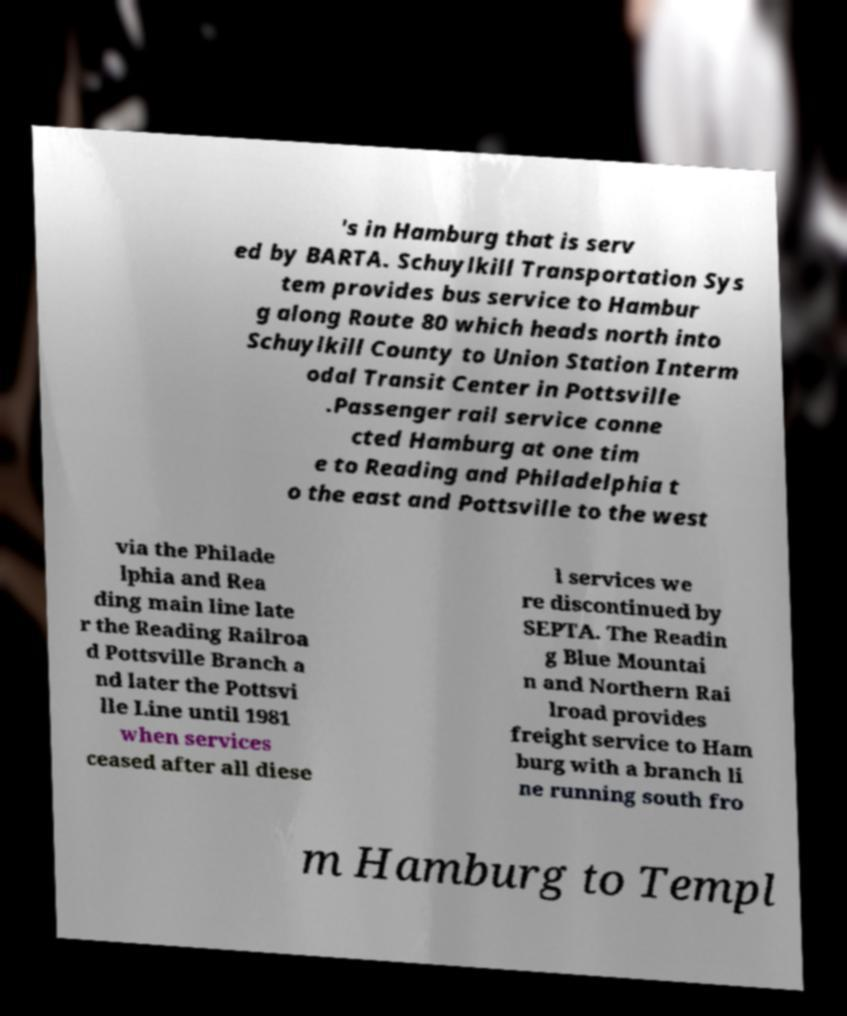Please read and relay the text visible in this image. What does it say? 's in Hamburg that is serv ed by BARTA. Schuylkill Transportation Sys tem provides bus service to Hambur g along Route 80 which heads north into Schuylkill County to Union Station Interm odal Transit Center in Pottsville .Passenger rail service conne cted Hamburg at one tim e to Reading and Philadelphia t o the east and Pottsville to the west via the Philade lphia and Rea ding main line late r the Reading Railroa d Pottsville Branch a nd later the Pottsvi lle Line until 1981 when services ceased after all diese l services we re discontinued by SEPTA. The Readin g Blue Mountai n and Northern Rai lroad provides freight service to Ham burg with a branch li ne running south fro m Hamburg to Templ 